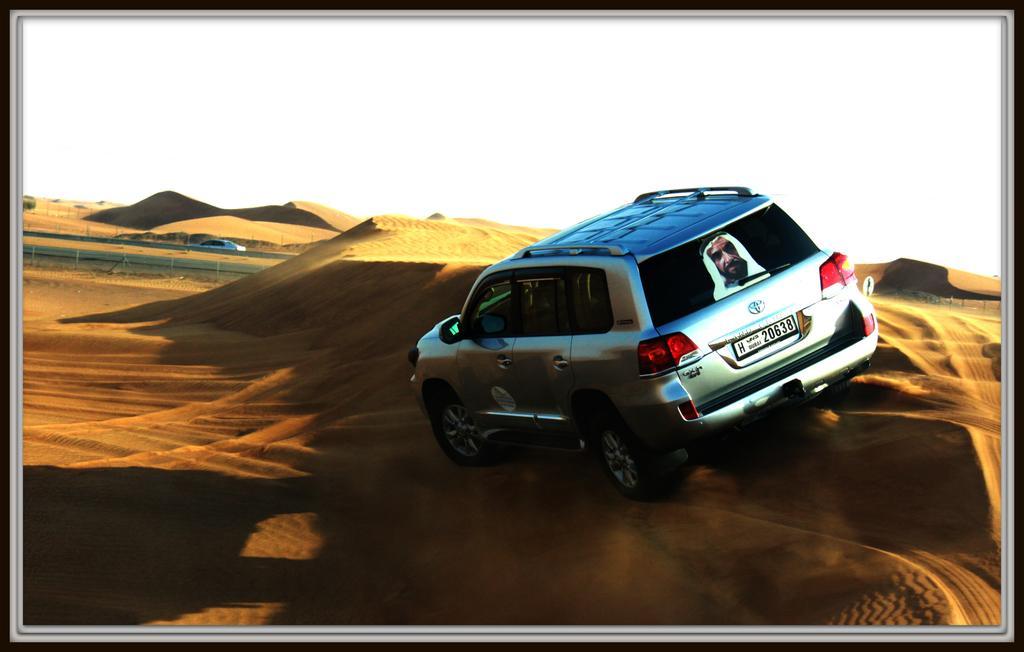In one or two sentences, can you explain what this image depicts? This picture seems to be an edited image with the borders. On the right we can see a car and we can see the picture of a person on the car and we can see the sand. In the background we can see the sky, a vehicle and some other objects. 